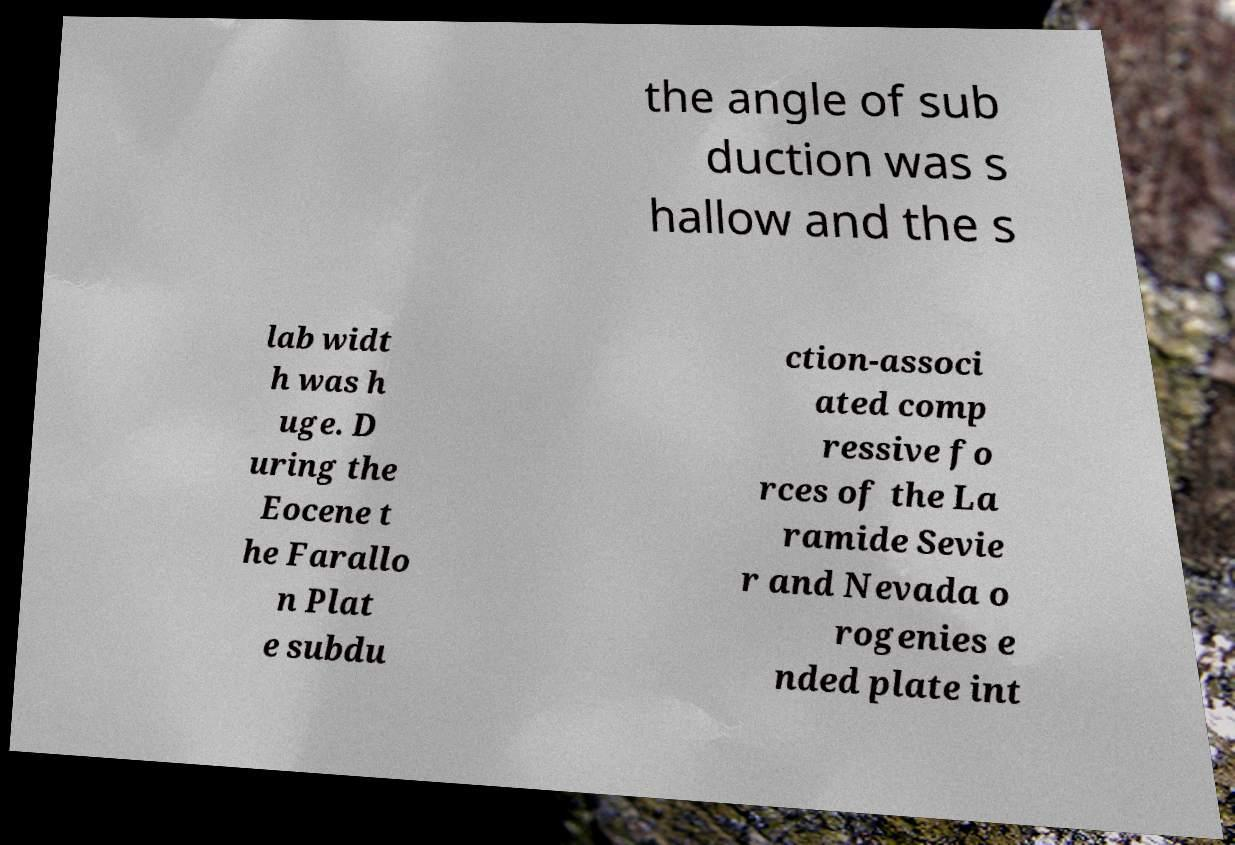I need the written content from this picture converted into text. Can you do that? the angle of sub duction was s hallow and the s lab widt h was h uge. D uring the Eocene t he Farallo n Plat e subdu ction-associ ated comp ressive fo rces of the La ramide Sevie r and Nevada o rogenies e nded plate int 